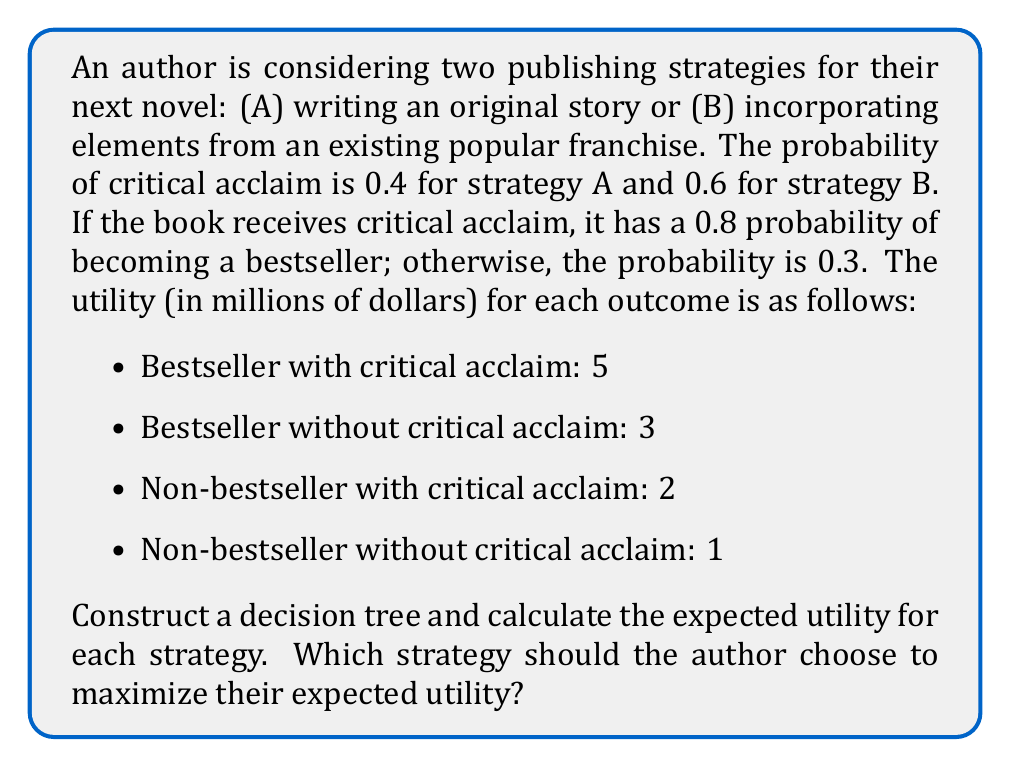Can you solve this math problem? Let's approach this problem step-by-step using decision trees and probability theory:

1. Construct the decision tree:

[asy]
import geometry;

pair A = (0,0), B = (100,50), C = (100,-50);
pair D1 = (200,75), D2 = (200,25), D3 = (200,-25), D4 = (200,-75);
pair E1 = (300,87.5), E2 = (300,62.5), E3 = (300,37.5), E4 = (300,12.5);
pair F1 = (300,-12.5), F2 = (300,-37.5), F3 = (300,-62.5), F4 = (300,-87.5);

draw(A--B--D1--E1, arrow=Arrow(TeXHead));
draw(B--D2--E2, arrow=Arrow(TeXHead));
draw(A--C--D3--F1, arrow=Arrow(TeXHead));
draw(C--D4--F2, arrow=Arrow(TeXHead));

label("A", B, W);
label("B", C, W);
label("0.4", (B+D1)/2, N);
label("0.6", (B+D2)/2, S);
label("0.6", (C+D3)/2, N);
label("0.4", (C+D4)/2, S);
label("0.8", (D1+E1)/2, N);
label("0.2", (D1+E2)/2, S);
label("0.3", (D2+E3)/2, N);
label("0.7", (D2+E4)/2, S);
label("0.8", (D3+F1)/2, N);
label("0.2", (D3+F2)/2, S);
label("0.3", (D4+F3)/2, N);
label("0.7", (D4+F4)/2, S);

label("5", E1, E);
label("2", E2, E);
label("3", E3, E);
label("1", E4, E);
label("5", F1, E);
label("2", F2, E);
label("3", F3, E);
label("1", F4, E);

[/asy]

2. Calculate the expected utility for each branch:

For Strategy A:
- $E(A_{1}) = 0.4 \times (0.8 \times 5 + 0.2 \times 2) = 1.76$
- $E(A_{2}) = 0.6 \times (0.3 \times 3 + 0.7 \times 1) = 1.08$
- $E(A) = E(A_{1}) + E(A_{2}) = 1.76 + 1.08 = 2.84$

For Strategy B:
- $E(B_{1}) = 0.6 \times (0.8 \times 5 + 0.2 \times 2) = 2.64$
- $E(B_{2}) = 0.4 \times (0.3 \times 3 + 0.7 \times 1) = 0.72$
- $E(B) = E(B_{1}) + E(B_{2}) = 2.64 + 0.72 = 3.36$

3. Compare the expected utilities:

Strategy A: $E(A) = 2.84$ million dollars
Strategy B: $E(B) = 3.36$ million dollars

Since $E(B) > E(A)$, Strategy B has a higher expected utility.
Answer: The author should choose Strategy B (incorporating elements from an existing popular franchise) to maximize their expected utility, as it has a higher expected value of $3.36 million compared to $2.84 million for Strategy A. 